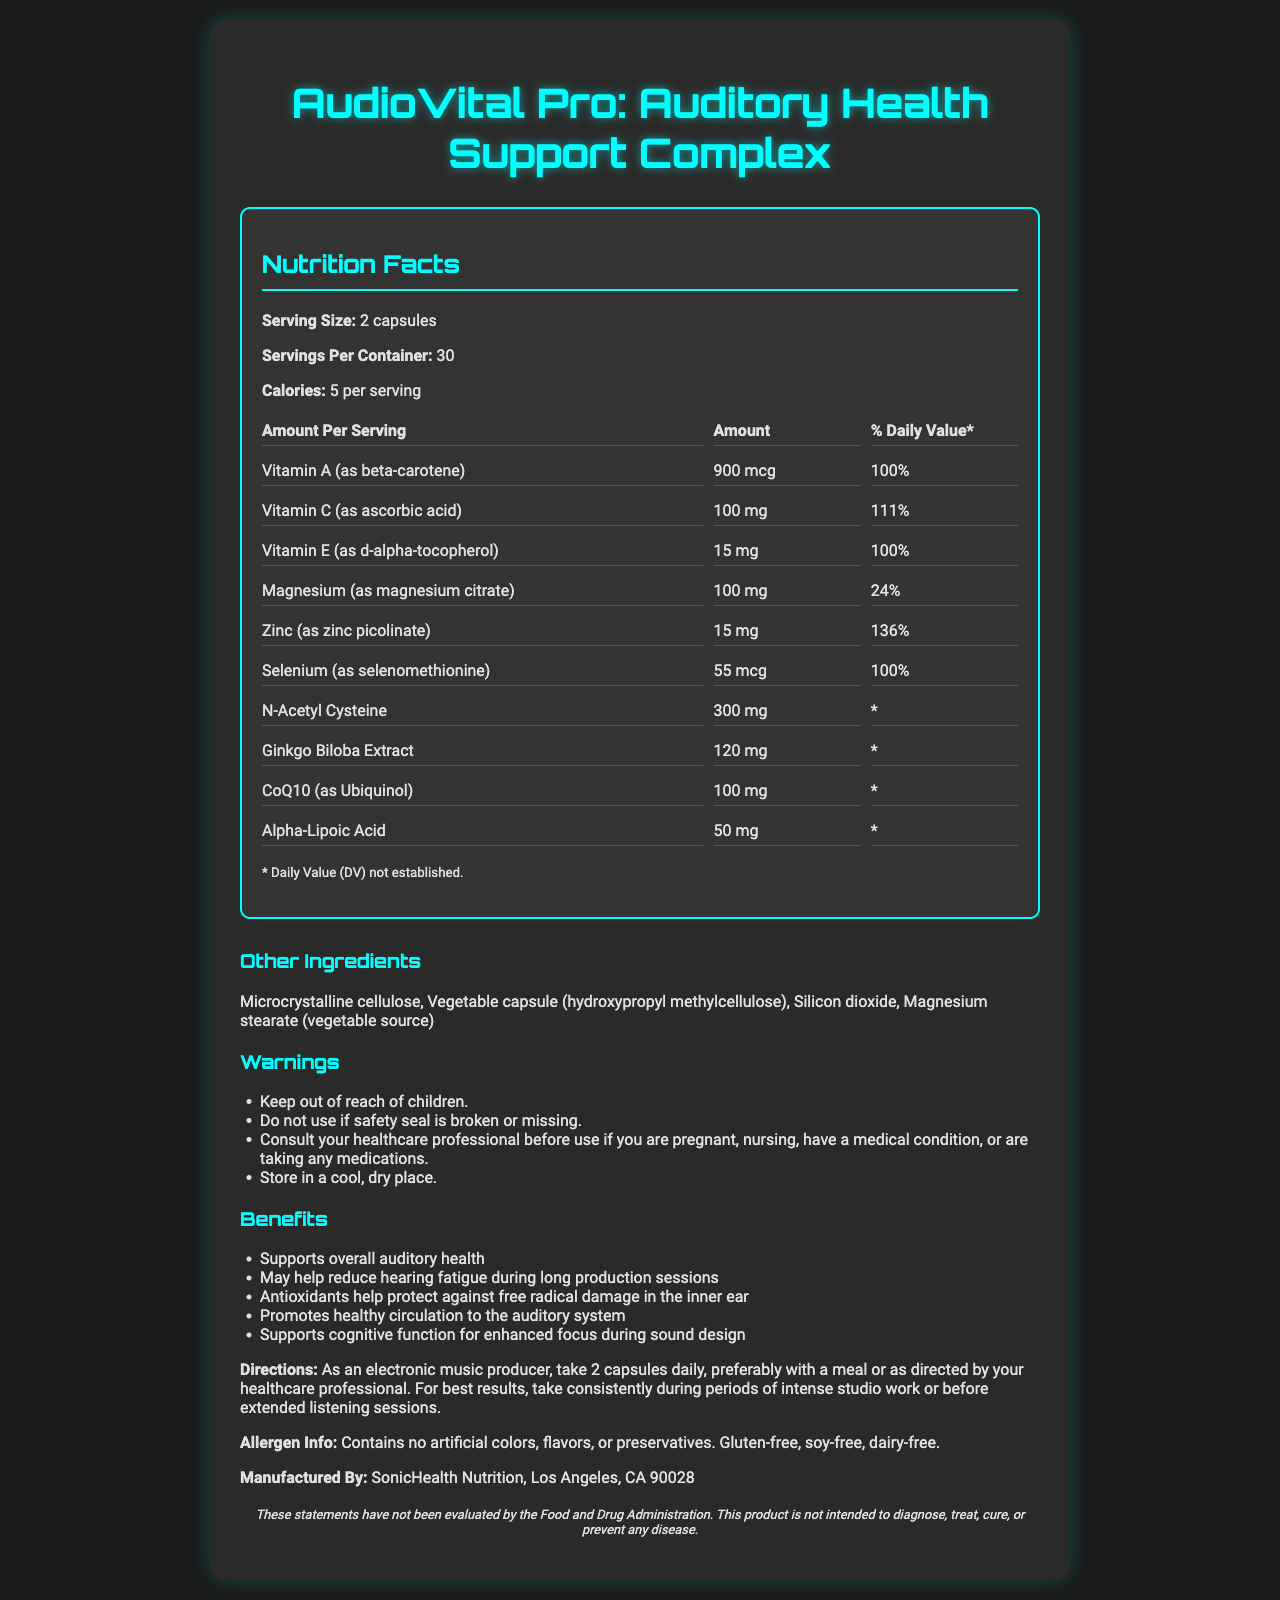what is the serving size of AudioVital Pro? The document specifies that the serving size of AudioVital Pro is 2 capsules.
Answer: 2 capsules how many calories are there per serving? The Nutrition Facts section of the document states that there are 5 calories per serving.
Answer: 5 calories what are the directions for taking AudioVital Pro? The directions are explicitly mentioned under the Directions section in the document.
Answer: Take 2 capsules daily, preferably with a meal or as directed by your healthcare professional. For best results, take consistently during periods of intense studio work or before extended listening sessions. which nutrient has the highest daily value percentage? The document states that Zinc has a daily value percentage of 136%, which is the highest among the listed nutrients.
Answer: Zinc what caution should be noted regarding storage? The warnings section mentions to store the product in a cool, dry place.
Answer: Store in a cool, dry place. does this product contain gluten? The allergen information states that the product is Gluten-free.
Answer: No which company manufactures AudioVital Pro? A. SonicHealth Nutrition B. HealthPro Labs C. VitalSounds Inc. D. NutriHealth Care E. AudioNutra The document lists that SonicHealth Nutrition, Los Angeles, CA 90028, manufactures AudioVital Pro.
Answer: A. SonicHealth Nutrition what is the percentage of the daily value of Vitamin C per serving? A. 90% B. 100% C. 111% D. 120% The nutrient details in the document state that Vitamin C has a daily value percentage of 111%.
Answer: C. 111% is AudioVital Pro intended to diagnose or treat any disease? The disclaimer clearly states that the product is not intended to diagnose, treat, cure, or prevent any disease.
Answer: No can you list the benefits mentioned in the document? The benefits section lists these detailed benefits of using AudioVital Pro.
Answer: Supports overall auditory health, May help reduce hearing fatigue during long production sessions, Antioxidants help protect against free radical damage in the inner ear, Promotes healthy circulation to the auditory system, Supports cognitive function for enhanced focus during sound design summarize the main purpose of AudioVital Pro. The document outlines the main objectives and target audience of AudioVital Pro along with its nutritional composition and benefits.
Answer: AudioVital Pro is designed to support auditory health and prevent hearing fatigue specifically for electronic music producers, audio engineers, and sound designers. It contains a mix of vitamins, minerals, and other nutrients aimed at protecting against free radical damage, promoting healthy circulation to the auditory system, and enhancing cognitive function for better focus during intense studio work. how many servings are there in each container of AudioVital Pro? The document specifies that there are 30 servings per container.
Answer: 30 servings what is the amount of N-Acetyl Cysteine per serving? The Nutrition Facts section lists N-Acetyl Cysteine as having an amount of 300 mg per serving.
Answer: 300 mg name an ingredient in the capsules other than the nutrients listed. The document lists Microcrystalline cellulose under other ingredients.
Answer: Microcrystalline cellulose is the product dairy-free? The allergen info specifies that the product is dairy-free.
Answer: Yes how should you take AudioVital Pro during periods of intense studio work? The directions section provides this information.
Answer: Take it consistently during periods of intense studio work or before extended listening sessions. is the daily value percentage of Alpha-Lipoic Acid established? The document mentions that the daily value for Alpha-Lipoic Acid is not established.
Answer: No what is the approximate amount of Vitamin A in each serving in mcg? The Nutrition Facts section indicates that each serving contains 900 mcg of Vitamin A.
Answer: 900 mcg should you consult a healthcare professional if you are pregnant before using AudioVital Pro? The warnings section advises consulting a healthcare professional before use if you are pregnant.
Answer: Yes what specific condition regarding safety seal is mentioned in the warnings? The warnings specify not to use the product if the safety seal is broken or missing.
Answer: Do not use if safety seal is broken or missing. who is the target audience for this product? The target audience is defined in the document explicitly mentioning these professions.
Answer: Electronic music producers, audio engineers, and sound designers how does CoQ10 contribute to the benefits of AudioVital Pro? The document lists CoQ10 as one of the nutrients but does not provide specific details on its individual benefits.
Answer: Cannot be determined 